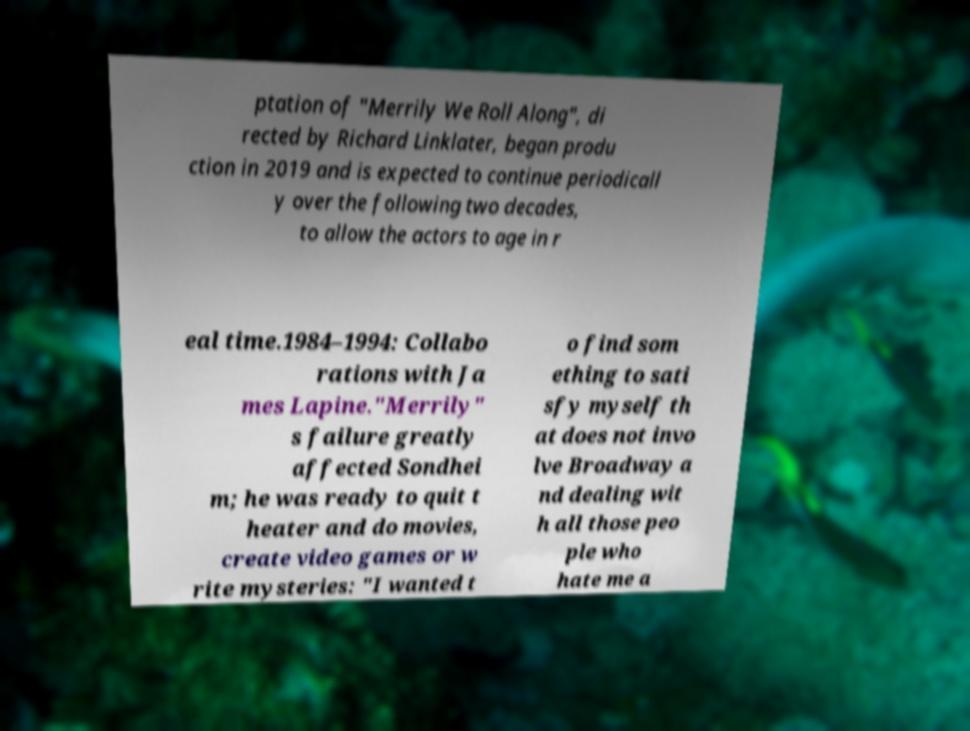Can you accurately transcribe the text from the provided image for me? ptation of "Merrily We Roll Along", di rected by Richard Linklater, began produ ction in 2019 and is expected to continue periodicall y over the following two decades, to allow the actors to age in r eal time.1984–1994: Collabo rations with Ja mes Lapine."Merrily" s failure greatly affected Sondhei m; he was ready to quit t heater and do movies, create video games or w rite mysteries: "I wanted t o find som ething to sati sfy myself th at does not invo lve Broadway a nd dealing wit h all those peo ple who hate me a 